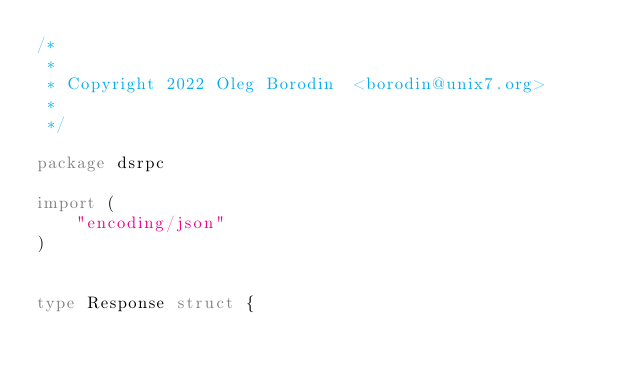Convert code to text. <code><loc_0><loc_0><loc_500><loc_500><_Go_>/*
 *
 * Copyright 2022 Oleg Borodin  <borodin@unix7.org>
 *
 */

package dsrpc

import (
    "encoding/json"
)


type Response struct {</code> 